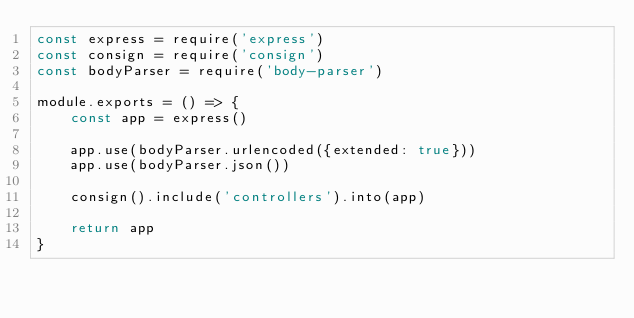<code> <loc_0><loc_0><loc_500><loc_500><_JavaScript_>const express = require('express')
const consign = require('consign')
const bodyParser = require('body-parser')

module.exports = () => {
    const app = express()

    app.use(bodyParser.urlencoded({extended: true}))
    app.use(bodyParser.json())

    consign().include('controllers').into(app)

    return app
}</code> 